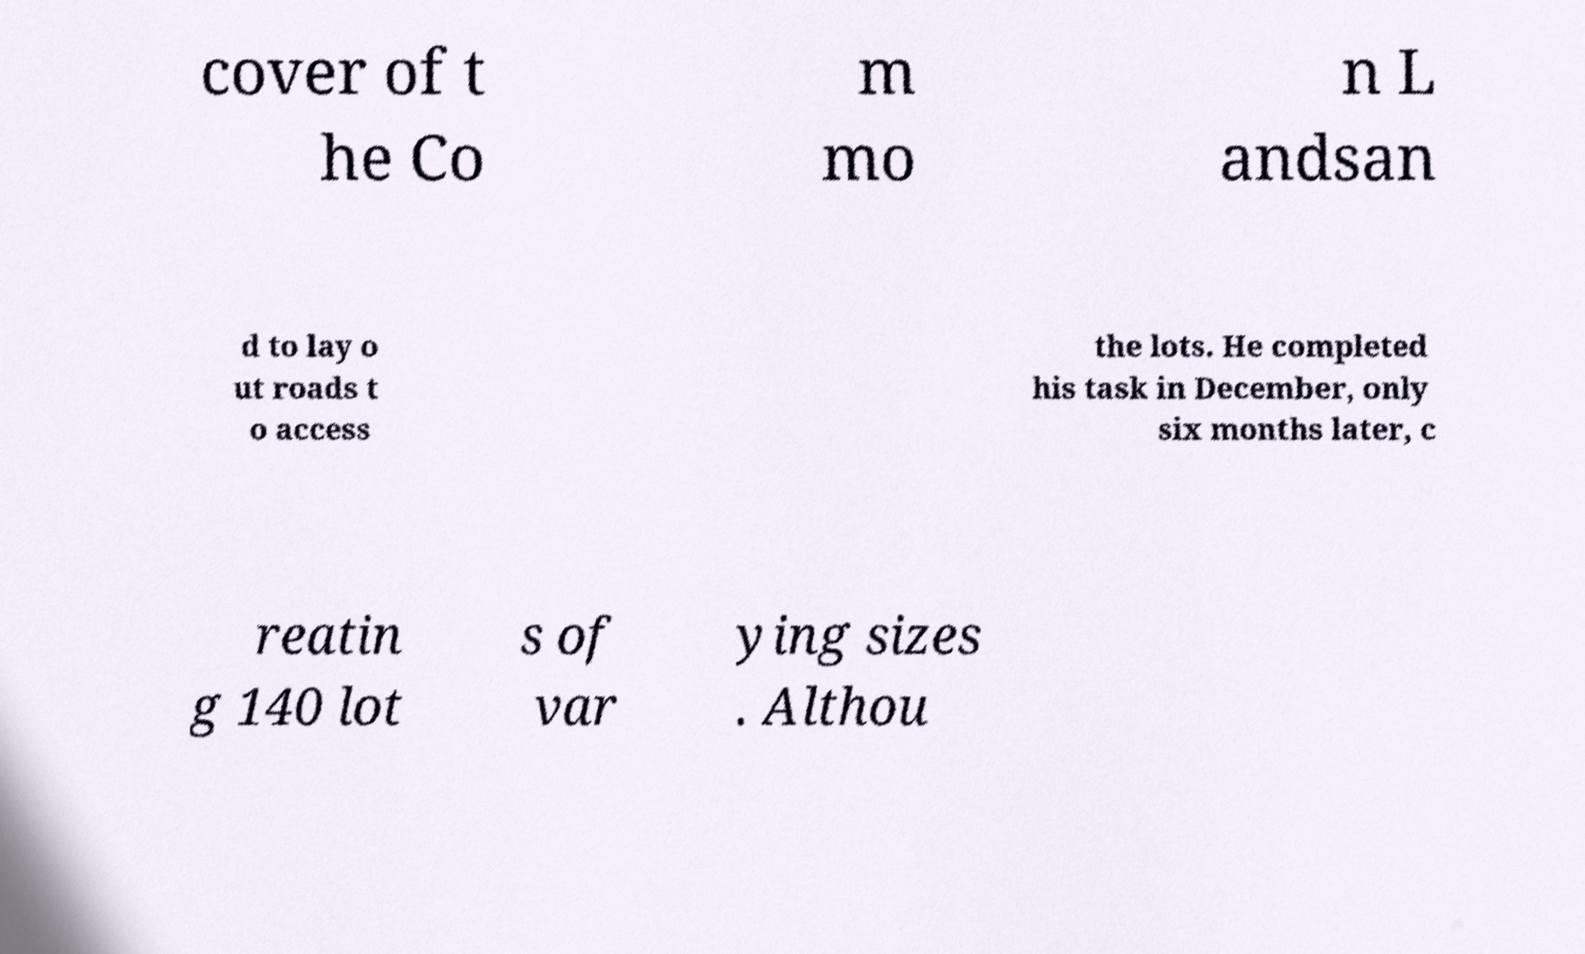Could you extract and type out the text from this image? cover of t he Co m mo n L andsan d to lay o ut roads t o access the lots. He completed his task in December, only six months later, c reatin g 140 lot s of var ying sizes . Althou 